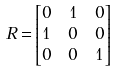Convert formula to latex. <formula><loc_0><loc_0><loc_500><loc_500>R = & \begin{bmatrix} 0 & 1 & 0 \\ 1 & 0 & 0 \\ 0 & 0 & 1 \end{bmatrix}</formula> 